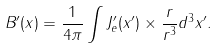Convert formula to latex. <formula><loc_0><loc_0><loc_500><loc_500>B ^ { \prime } ( x ) = \frac { 1 } { 4 \pi } \int J _ { e } ^ { \prime } ( x ^ { \prime } ) \times \frac { r } { r ^ { 3 } } d ^ { 3 } x ^ { \prime } .</formula> 